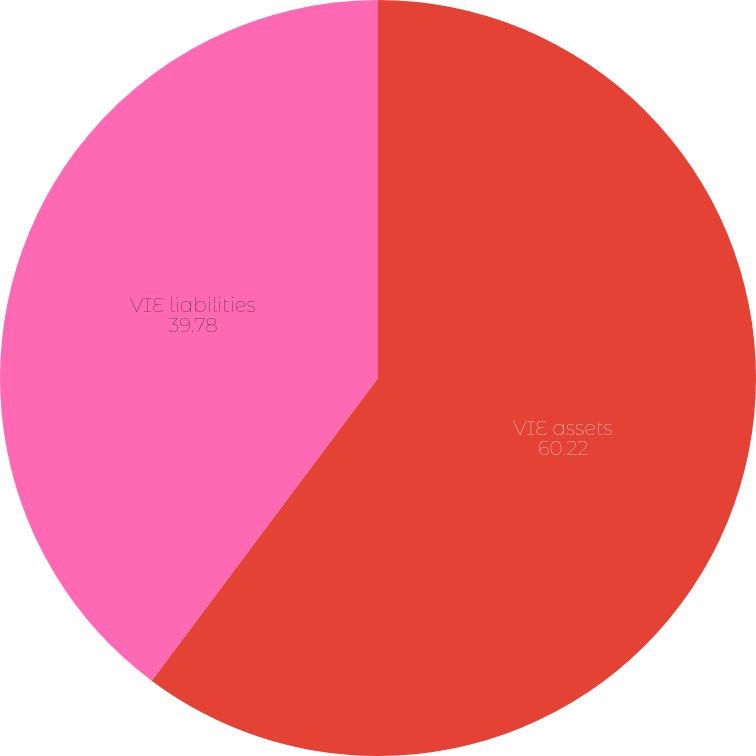<chart> <loc_0><loc_0><loc_500><loc_500><pie_chart><fcel>VIE assets<fcel>VIE liabilities<nl><fcel>60.22%<fcel>39.78%<nl></chart> 